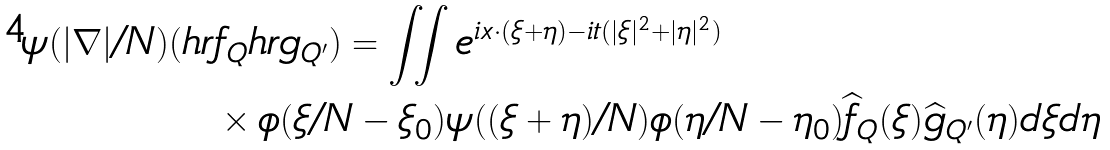Convert formula to latex. <formula><loc_0><loc_0><loc_500><loc_500>\psi ( | \nabla | / { N } ) ( h r & f _ { Q } h r g _ { Q ^ { \prime } } ) = \iint e ^ { i x \cdot ( \xi + \eta ) - i t ( | \xi | ^ { 2 } + | \eta | ^ { 2 } ) } \\ & \times \phi ( \xi / N - \xi _ { 0 } ) \psi ( ( \xi + \eta ) / N ) \phi ( \eta / N - \eta _ { 0 } ) \widehat { f } _ { Q } ( \xi ) \widehat { g } _ { Q ^ { \prime } } ( \eta ) d \xi d \eta</formula> 